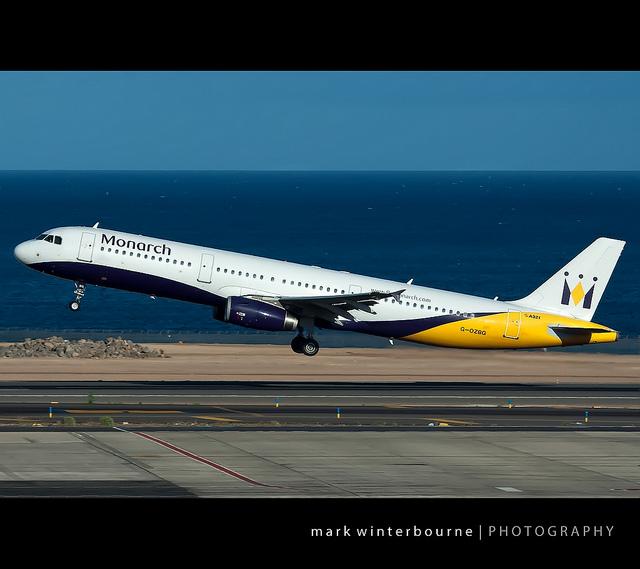What color is the plane?
Write a very short answer. White. Is the plane taking off?
Quick response, please. Yes. What is the weather like?
Keep it brief. Sunny. How many yellow doors are there?
Concise answer only. 1. Is the plane in motion?
Keep it brief. Yes. 